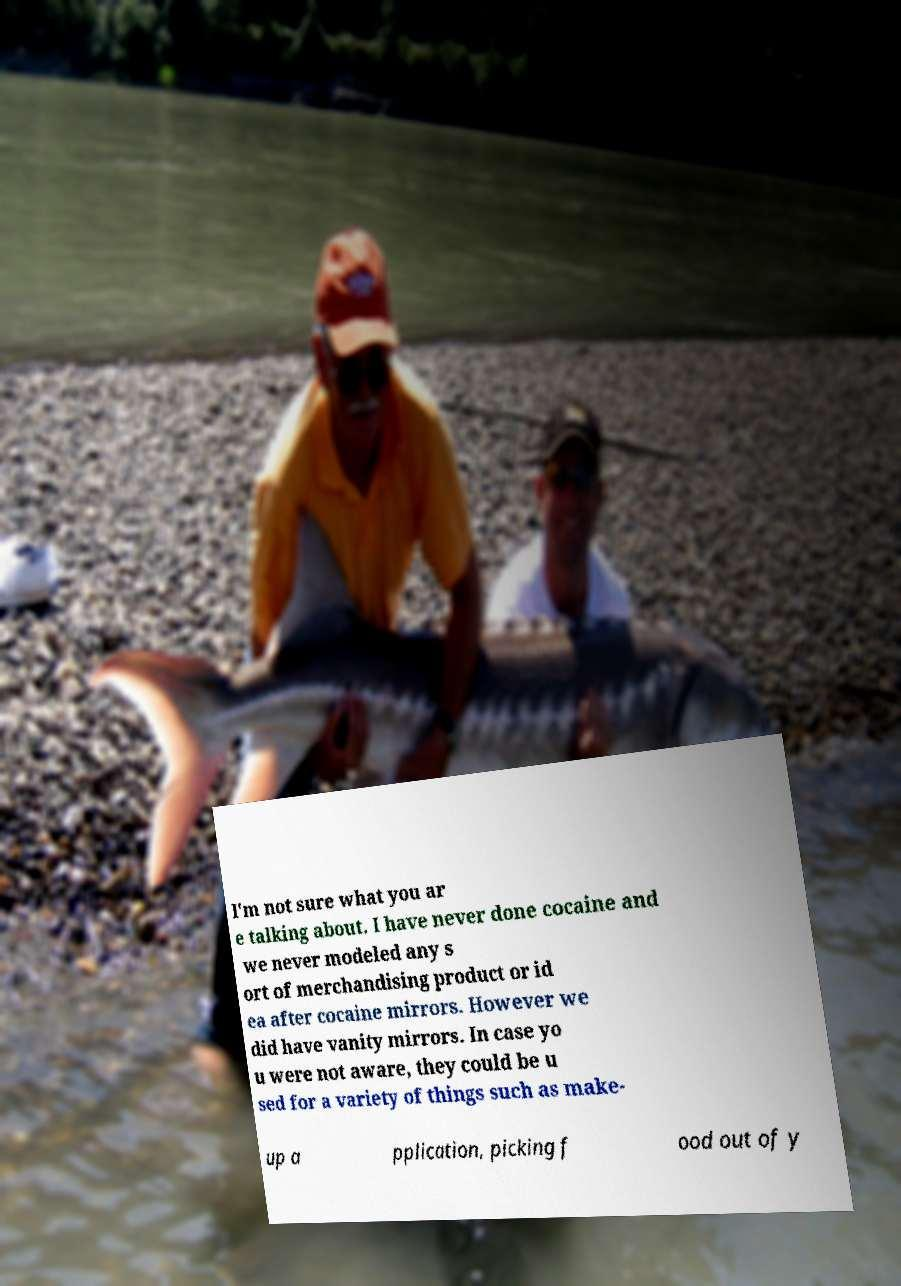Please read and relay the text visible in this image. What does it say? I'm not sure what you ar e talking about. I have never done cocaine and we never modeled any s ort of merchandising product or id ea after cocaine mirrors. However we did have vanity mirrors. In case yo u were not aware, they could be u sed for a variety of things such as make- up a pplication, picking f ood out of y 